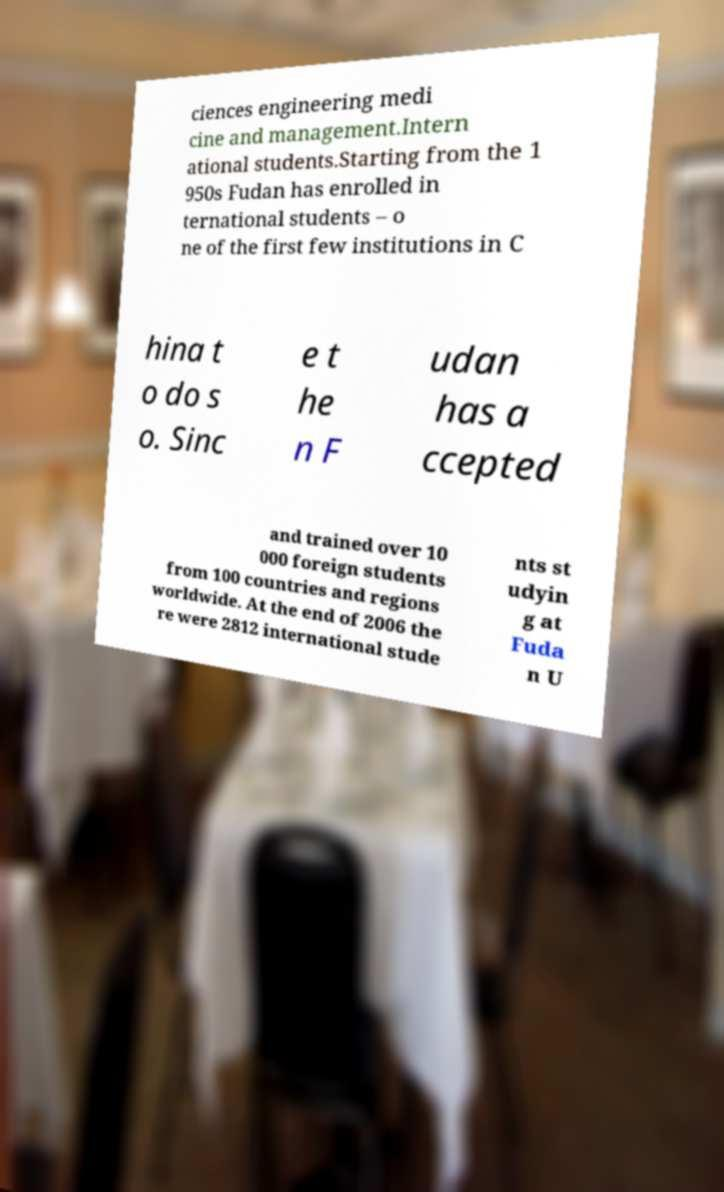Please identify and transcribe the text found in this image. ciences engineering medi cine and management.Intern ational students.Starting from the 1 950s Fudan has enrolled in ternational students – o ne of the first few institutions in C hina t o do s o. Sinc e t he n F udan has a ccepted and trained over 10 000 foreign students from 100 countries and regions worldwide. At the end of 2006 the re were 2812 international stude nts st udyin g at Fuda n U 